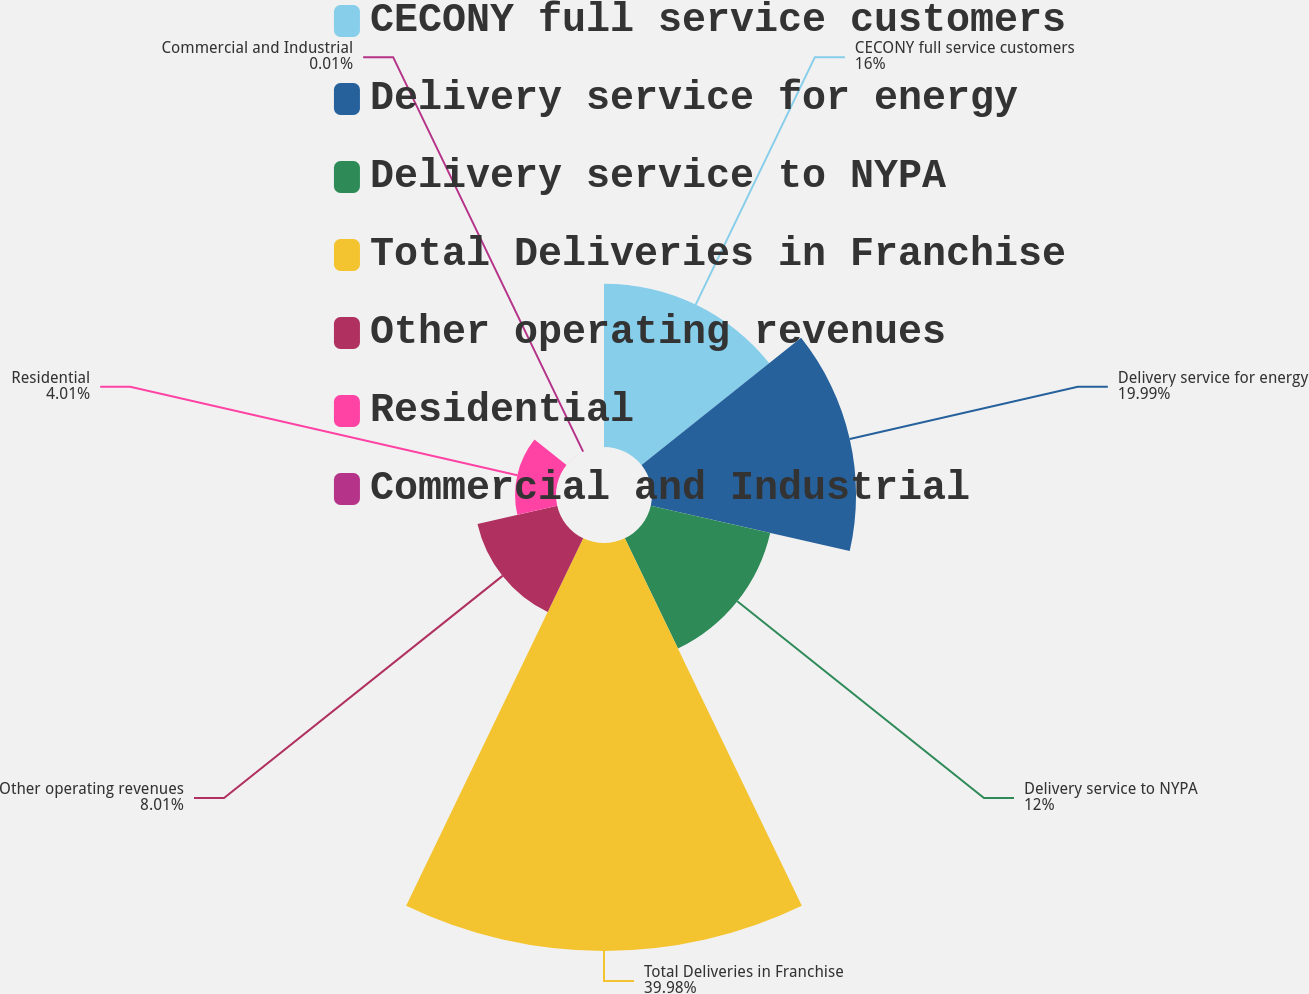Convert chart. <chart><loc_0><loc_0><loc_500><loc_500><pie_chart><fcel>CECONY full service customers<fcel>Delivery service for energy<fcel>Delivery service to NYPA<fcel>Total Deliveries in Franchise<fcel>Other operating revenues<fcel>Residential<fcel>Commercial and Industrial<nl><fcel>16.0%<fcel>19.99%<fcel>12.0%<fcel>39.97%<fcel>8.01%<fcel>4.01%<fcel>0.01%<nl></chart> 